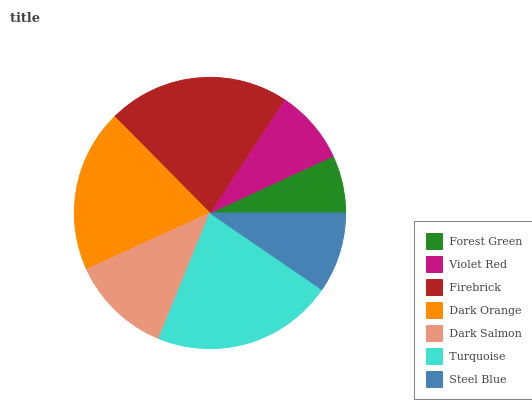Is Forest Green the minimum?
Answer yes or no. Yes. Is Firebrick the maximum?
Answer yes or no. Yes. Is Violet Red the minimum?
Answer yes or no. No. Is Violet Red the maximum?
Answer yes or no. No. Is Violet Red greater than Forest Green?
Answer yes or no. Yes. Is Forest Green less than Violet Red?
Answer yes or no. Yes. Is Forest Green greater than Violet Red?
Answer yes or no. No. Is Violet Red less than Forest Green?
Answer yes or no. No. Is Dark Salmon the high median?
Answer yes or no. Yes. Is Dark Salmon the low median?
Answer yes or no. Yes. Is Dark Orange the high median?
Answer yes or no. No. Is Turquoise the low median?
Answer yes or no. No. 